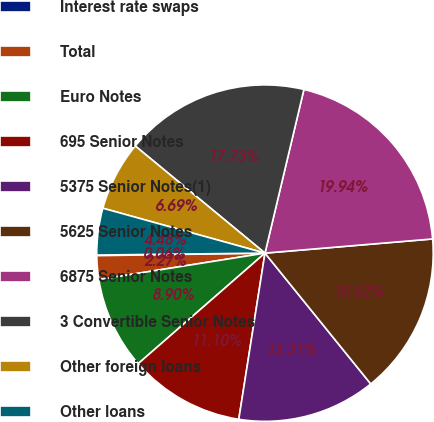Convert chart. <chart><loc_0><loc_0><loc_500><loc_500><pie_chart><fcel>Interest rate swaps<fcel>Total<fcel>Euro Notes<fcel>695 Senior Notes<fcel>5375 Senior Notes(1)<fcel>5625 Senior Notes<fcel>6875 Senior Notes<fcel>3 Convertible Senior Notes<fcel>Other foreign loans<fcel>Other loans<nl><fcel>0.06%<fcel>2.27%<fcel>8.9%<fcel>11.1%<fcel>13.31%<fcel>15.52%<fcel>19.94%<fcel>17.73%<fcel>6.69%<fcel>4.48%<nl></chart> 